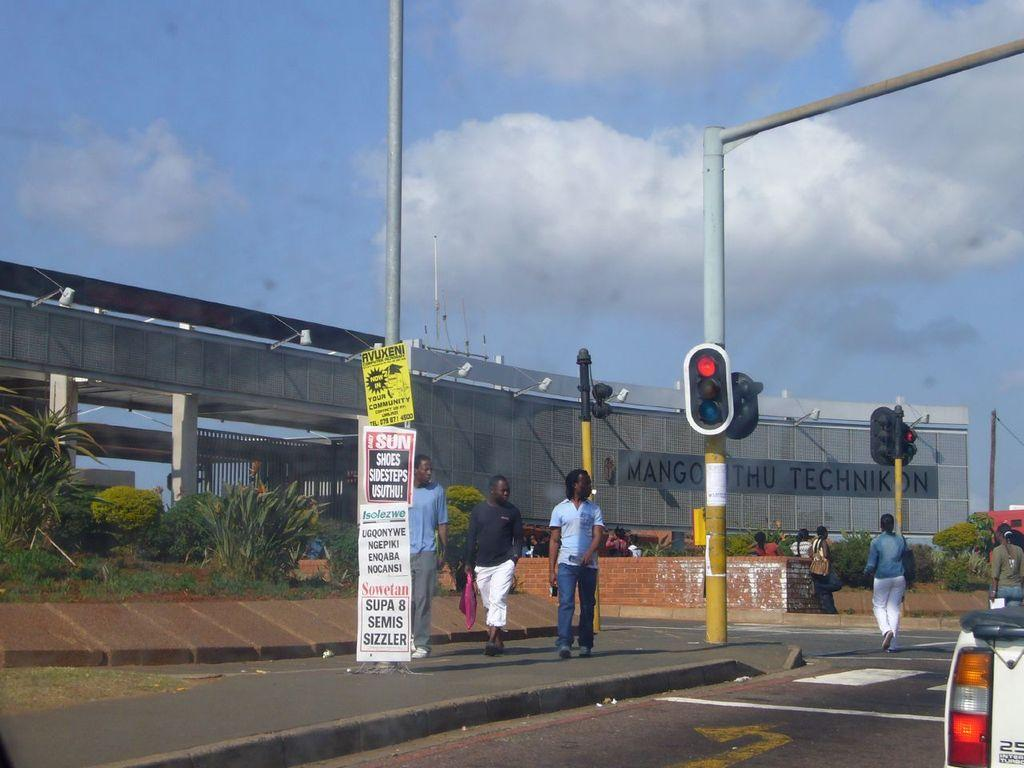<image>
Relay a brief, clear account of the picture shown. the word shoes is on a sign outside 